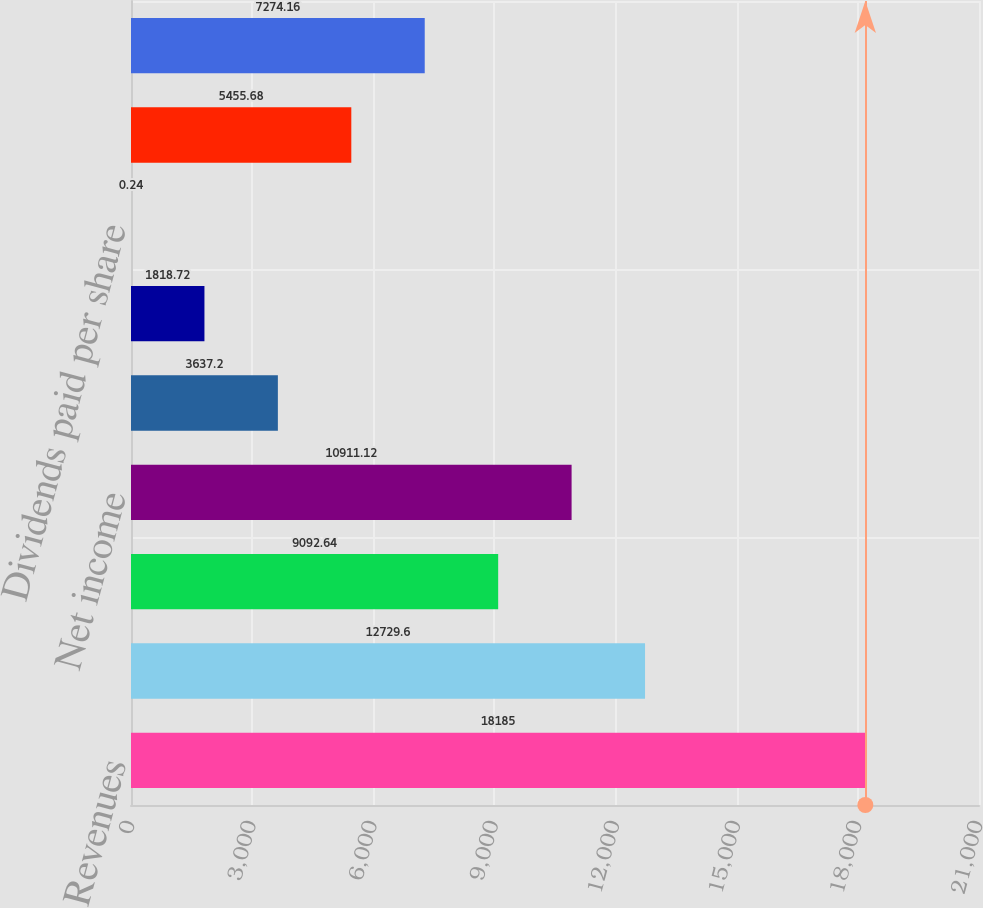<chart> <loc_0><loc_0><loc_500><loc_500><bar_chart><fcel>Revenues<fcel>Income from operations<fcel>Income from continuing<fcel>Net income<fcel>- Basic<fcel>- Diluted<fcel>Dividends paid per share<fcel>- Low<fcel>- High<nl><fcel>18185<fcel>12729.6<fcel>9092.64<fcel>10911.1<fcel>3637.2<fcel>1818.72<fcel>0.24<fcel>5455.68<fcel>7274.16<nl></chart> 